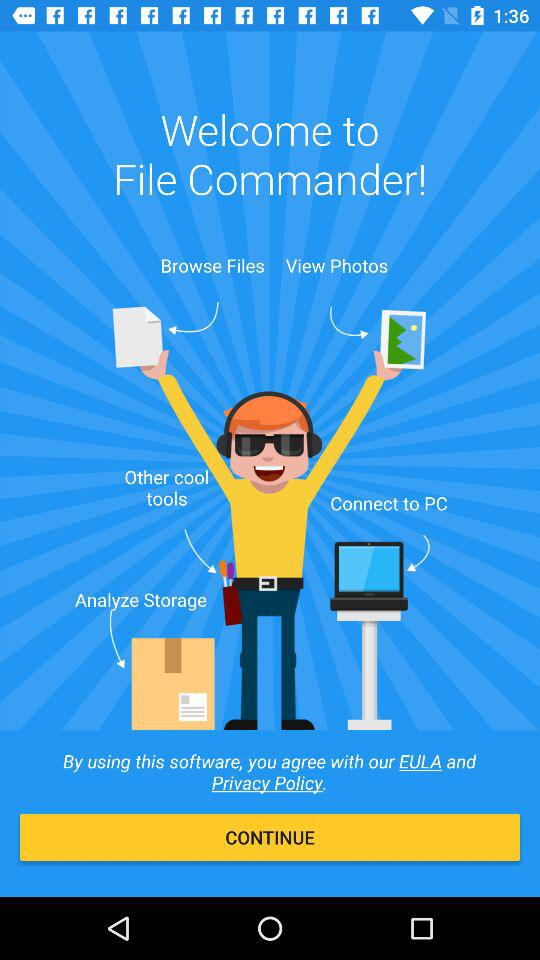What is the application name? The application name is "File Commander". 